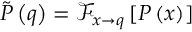Convert formula to latex. <formula><loc_0><loc_0><loc_500><loc_500>\tilde { P } \left ( q \right ) = \mathcal { F } _ { x \rightarrow q } \left [ P \left ( x \right ) \right ]</formula> 